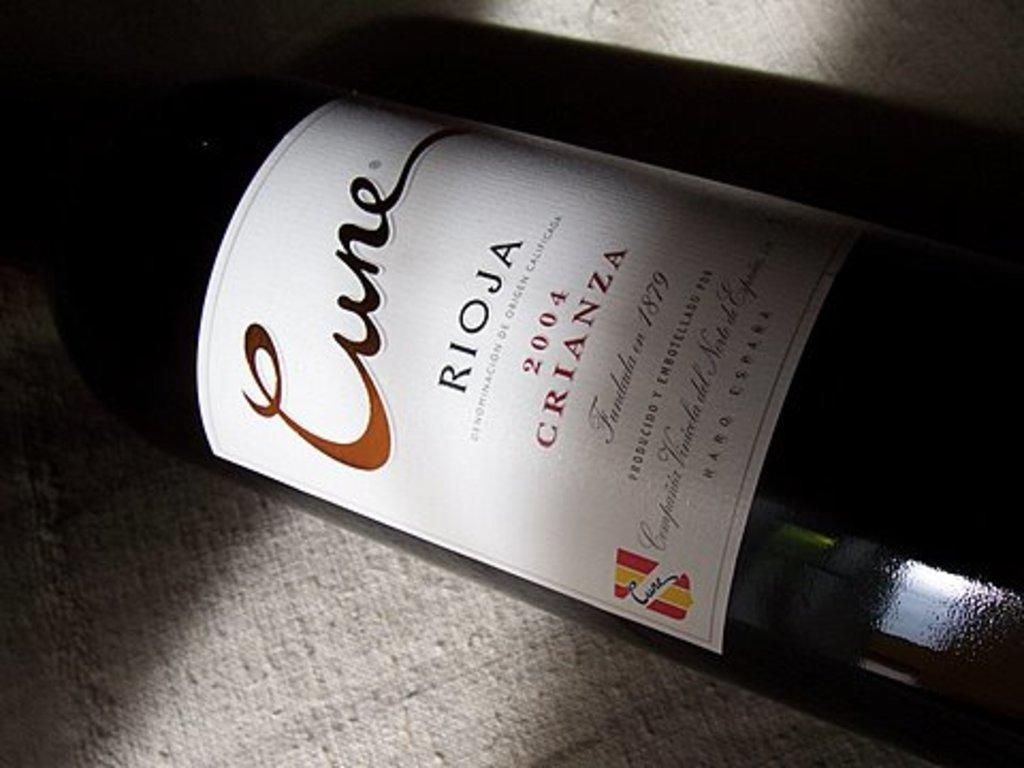<image>
Relay a brief, clear account of the picture shown. A bottle of Cune Rioja that was bottled in 04. 